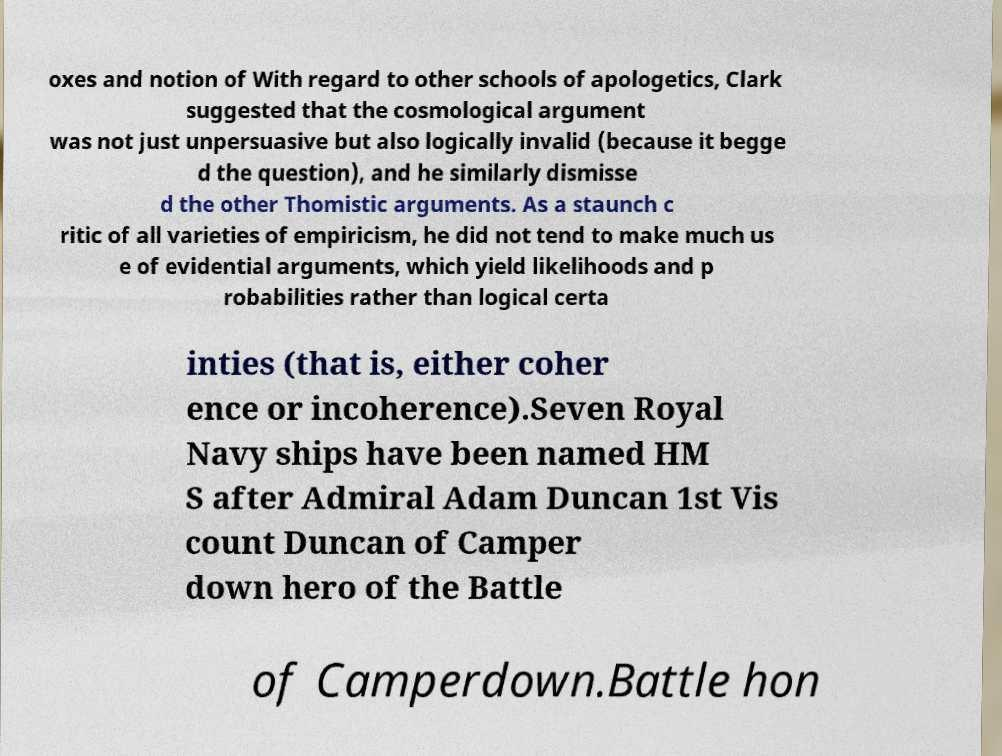What messages or text are displayed in this image? I need them in a readable, typed format. oxes and notion of With regard to other schools of apologetics, Clark suggested that the cosmological argument was not just unpersuasive but also logically invalid (because it begge d the question), and he similarly dismisse d the other Thomistic arguments. As a staunch c ritic of all varieties of empiricism, he did not tend to make much us e of evidential arguments, which yield likelihoods and p robabilities rather than logical certa inties (that is, either coher ence or incoherence).Seven Royal Navy ships have been named HM S after Admiral Adam Duncan 1st Vis count Duncan of Camper down hero of the Battle of Camperdown.Battle hon 